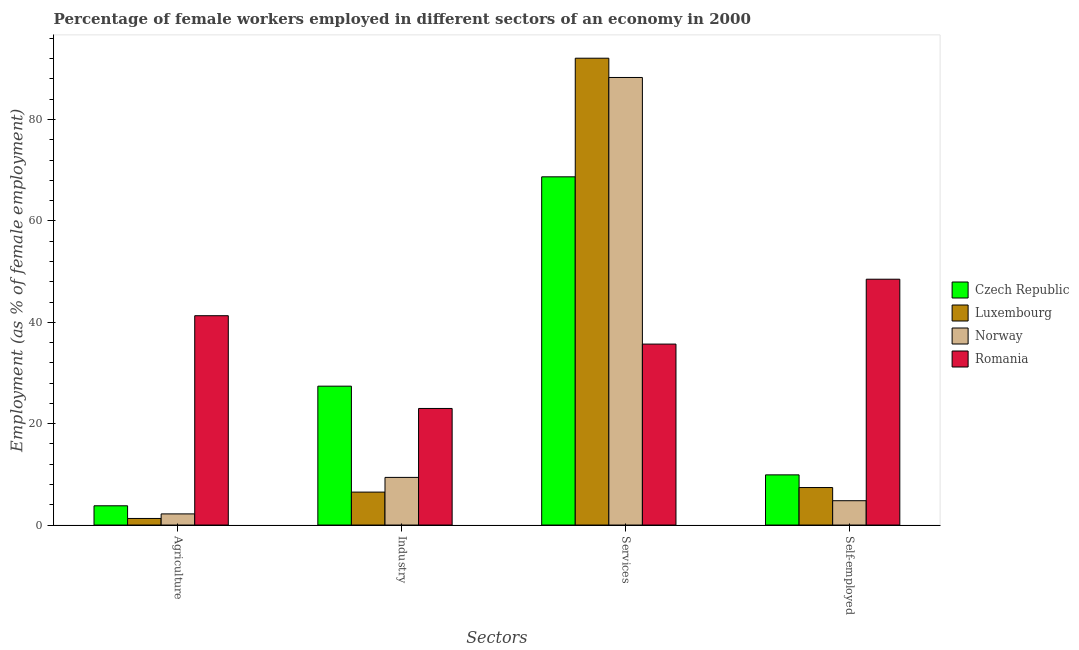How many different coloured bars are there?
Your answer should be very brief. 4. How many groups of bars are there?
Keep it short and to the point. 4. Are the number of bars on each tick of the X-axis equal?
Provide a short and direct response. Yes. How many bars are there on the 2nd tick from the right?
Provide a short and direct response. 4. What is the label of the 4th group of bars from the left?
Ensure brevity in your answer.  Self-employed. What is the percentage of female workers in agriculture in Luxembourg?
Your answer should be compact. 1.3. Across all countries, what is the maximum percentage of self employed female workers?
Offer a terse response. 48.5. Across all countries, what is the minimum percentage of female workers in agriculture?
Give a very brief answer. 1.3. In which country was the percentage of female workers in industry maximum?
Give a very brief answer. Czech Republic. What is the total percentage of female workers in services in the graph?
Ensure brevity in your answer.  284.8. What is the difference between the percentage of self employed female workers in Luxembourg and that in Norway?
Offer a very short reply. 2.6. What is the difference between the percentage of female workers in agriculture in Norway and the percentage of female workers in services in Luxembourg?
Your response must be concise. -89.9. What is the average percentage of female workers in industry per country?
Keep it short and to the point. 16.57. What is the difference between the percentage of female workers in services and percentage of female workers in agriculture in Luxembourg?
Keep it short and to the point. 90.8. What is the ratio of the percentage of female workers in services in Luxembourg to that in Czech Republic?
Offer a terse response. 1.34. Is the percentage of female workers in industry in Romania less than that in Norway?
Your answer should be compact. No. What is the difference between the highest and the second highest percentage of self employed female workers?
Keep it short and to the point. 38.6. What is the difference between the highest and the lowest percentage of female workers in services?
Your answer should be compact. 56.4. In how many countries, is the percentage of female workers in industry greater than the average percentage of female workers in industry taken over all countries?
Ensure brevity in your answer.  2. Is the sum of the percentage of self employed female workers in Luxembourg and Norway greater than the maximum percentage of female workers in industry across all countries?
Offer a very short reply. No. Is it the case that in every country, the sum of the percentage of self employed female workers and percentage of female workers in agriculture is greater than the sum of percentage of female workers in services and percentage of female workers in industry?
Your answer should be compact. No. What does the 4th bar from the left in Services represents?
Your answer should be very brief. Romania. What does the 1st bar from the right in Self-employed represents?
Give a very brief answer. Romania. Is it the case that in every country, the sum of the percentage of female workers in agriculture and percentage of female workers in industry is greater than the percentage of female workers in services?
Provide a succinct answer. No. How many bars are there?
Your answer should be compact. 16. Are the values on the major ticks of Y-axis written in scientific E-notation?
Provide a succinct answer. No. Does the graph contain grids?
Give a very brief answer. No. Where does the legend appear in the graph?
Your answer should be very brief. Center right. What is the title of the graph?
Ensure brevity in your answer.  Percentage of female workers employed in different sectors of an economy in 2000. What is the label or title of the X-axis?
Your answer should be very brief. Sectors. What is the label or title of the Y-axis?
Make the answer very short. Employment (as % of female employment). What is the Employment (as % of female employment) in Czech Republic in Agriculture?
Your answer should be compact. 3.8. What is the Employment (as % of female employment) of Luxembourg in Agriculture?
Keep it short and to the point. 1.3. What is the Employment (as % of female employment) of Norway in Agriculture?
Keep it short and to the point. 2.2. What is the Employment (as % of female employment) in Romania in Agriculture?
Your answer should be very brief. 41.3. What is the Employment (as % of female employment) of Czech Republic in Industry?
Your response must be concise. 27.4. What is the Employment (as % of female employment) of Norway in Industry?
Keep it short and to the point. 9.4. What is the Employment (as % of female employment) in Romania in Industry?
Your answer should be compact. 23. What is the Employment (as % of female employment) of Czech Republic in Services?
Offer a very short reply. 68.7. What is the Employment (as % of female employment) of Luxembourg in Services?
Your answer should be compact. 92.1. What is the Employment (as % of female employment) of Norway in Services?
Provide a short and direct response. 88.3. What is the Employment (as % of female employment) in Romania in Services?
Offer a very short reply. 35.7. What is the Employment (as % of female employment) of Czech Republic in Self-employed?
Your answer should be compact. 9.9. What is the Employment (as % of female employment) of Luxembourg in Self-employed?
Provide a succinct answer. 7.4. What is the Employment (as % of female employment) in Norway in Self-employed?
Offer a terse response. 4.8. What is the Employment (as % of female employment) in Romania in Self-employed?
Keep it short and to the point. 48.5. Across all Sectors, what is the maximum Employment (as % of female employment) in Czech Republic?
Keep it short and to the point. 68.7. Across all Sectors, what is the maximum Employment (as % of female employment) in Luxembourg?
Offer a terse response. 92.1. Across all Sectors, what is the maximum Employment (as % of female employment) of Norway?
Ensure brevity in your answer.  88.3. Across all Sectors, what is the maximum Employment (as % of female employment) of Romania?
Provide a short and direct response. 48.5. Across all Sectors, what is the minimum Employment (as % of female employment) in Czech Republic?
Offer a terse response. 3.8. Across all Sectors, what is the minimum Employment (as % of female employment) in Luxembourg?
Provide a succinct answer. 1.3. Across all Sectors, what is the minimum Employment (as % of female employment) of Norway?
Offer a terse response. 2.2. What is the total Employment (as % of female employment) of Czech Republic in the graph?
Make the answer very short. 109.8. What is the total Employment (as % of female employment) of Luxembourg in the graph?
Make the answer very short. 107.3. What is the total Employment (as % of female employment) in Norway in the graph?
Keep it short and to the point. 104.7. What is the total Employment (as % of female employment) of Romania in the graph?
Provide a short and direct response. 148.5. What is the difference between the Employment (as % of female employment) of Czech Republic in Agriculture and that in Industry?
Provide a short and direct response. -23.6. What is the difference between the Employment (as % of female employment) of Norway in Agriculture and that in Industry?
Your answer should be compact. -7.2. What is the difference between the Employment (as % of female employment) of Czech Republic in Agriculture and that in Services?
Ensure brevity in your answer.  -64.9. What is the difference between the Employment (as % of female employment) in Luxembourg in Agriculture and that in Services?
Offer a terse response. -90.8. What is the difference between the Employment (as % of female employment) of Norway in Agriculture and that in Services?
Offer a very short reply. -86.1. What is the difference between the Employment (as % of female employment) of Romania in Agriculture and that in Services?
Your answer should be compact. 5.6. What is the difference between the Employment (as % of female employment) in Czech Republic in Agriculture and that in Self-employed?
Give a very brief answer. -6.1. What is the difference between the Employment (as % of female employment) of Romania in Agriculture and that in Self-employed?
Your response must be concise. -7.2. What is the difference between the Employment (as % of female employment) of Czech Republic in Industry and that in Services?
Provide a short and direct response. -41.3. What is the difference between the Employment (as % of female employment) of Luxembourg in Industry and that in Services?
Provide a short and direct response. -85.6. What is the difference between the Employment (as % of female employment) of Norway in Industry and that in Services?
Offer a very short reply. -78.9. What is the difference between the Employment (as % of female employment) of Romania in Industry and that in Services?
Your answer should be compact. -12.7. What is the difference between the Employment (as % of female employment) of Czech Republic in Industry and that in Self-employed?
Ensure brevity in your answer.  17.5. What is the difference between the Employment (as % of female employment) of Luxembourg in Industry and that in Self-employed?
Ensure brevity in your answer.  -0.9. What is the difference between the Employment (as % of female employment) of Romania in Industry and that in Self-employed?
Your answer should be compact. -25.5. What is the difference between the Employment (as % of female employment) in Czech Republic in Services and that in Self-employed?
Your response must be concise. 58.8. What is the difference between the Employment (as % of female employment) in Luxembourg in Services and that in Self-employed?
Make the answer very short. 84.7. What is the difference between the Employment (as % of female employment) of Norway in Services and that in Self-employed?
Your response must be concise. 83.5. What is the difference between the Employment (as % of female employment) in Czech Republic in Agriculture and the Employment (as % of female employment) in Norway in Industry?
Make the answer very short. -5.6. What is the difference between the Employment (as % of female employment) of Czech Republic in Agriculture and the Employment (as % of female employment) of Romania in Industry?
Provide a short and direct response. -19.2. What is the difference between the Employment (as % of female employment) in Luxembourg in Agriculture and the Employment (as % of female employment) in Romania in Industry?
Offer a terse response. -21.7. What is the difference between the Employment (as % of female employment) of Norway in Agriculture and the Employment (as % of female employment) of Romania in Industry?
Provide a short and direct response. -20.8. What is the difference between the Employment (as % of female employment) in Czech Republic in Agriculture and the Employment (as % of female employment) in Luxembourg in Services?
Give a very brief answer. -88.3. What is the difference between the Employment (as % of female employment) in Czech Republic in Agriculture and the Employment (as % of female employment) in Norway in Services?
Make the answer very short. -84.5. What is the difference between the Employment (as % of female employment) of Czech Republic in Agriculture and the Employment (as % of female employment) of Romania in Services?
Keep it short and to the point. -31.9. What is the difference between the Employment (as % of female employment) in Luxembourg in Agriculture and the Employment (as % of female employment) in Norway in Services?
Give a very brief answer. -87. What is the difference between the Employment (as % of female employment) in Luxembourg in Agriculture and the Employment (as % of female employment) in Romania in Services?
Make the answer very short. -34.4. What is the difference between the Employment (as % of female employment) of Norway in Agriculture and the Employment (as % of female employment) of Romania in Services?
Your response must be concise. -33.5. What is the difference between the Employment (as % of female employment) in Czech Republic in Agriculture and the Employment (as % of female employment) in Luxembourg in Self-employed?
Offer a terse response. -3.6. What is the difference between the Employment (as % of female employment) in Czech Republic in Agriculture and the Employment (as % of female employment) in Norway in Self-employed?
Your answer should be compact. -1. What is the difference between the Employment (as % of female employment) of Czech Republic in Agriculture and the Employment (as % of female employment) of Romania in Self-employed?
Offer a very short reply. -44.7. What is the difference between the Employment (as % of female employment) in Luxembourg in Agriculture and the Employment (as % of female employment) in Norway in Self-employed?
Your response must be concise. -3.5. What is the difference between the Employment (as % of female employment) of Luxembourg in Agriculture and the Employment (as % of female employment) of Romania in Self-employed?
Your answer should be compact. -47.2. What is the difference between the Employment (as % of female employment) in Norway in Agriculture and the Employment (as % of female employment) in Romania in Self-employed?
Your answer should be compact. -46.3. What is the difference between the Employment (as % of female employment) in Czech Republic in Industry and the Employment (as % of female employment) in Luxembourg in Services?
Your answer should be compact. -64.7. What is the difference between the Employment (as % of female employment) of Czech Republic in Industry and the Employment (as % of female employment) of Norway in Services?
Your answer should be very brief. -60.9. What is the difference between the Employment (as % of female employment) of Luxembourg in Industry and the Employment (as % of female employment) of Norway in Services?
Your answer should be very brief. -81.8. What is the difference between the Employment (as % of female employment) of Luxembourg in Industry and the Employment (as % of female employment) of Romania in Services?
Your answer should be compact. -29.2. What is the difference between the Employment (as % of female employment) in Norway in Industry and the Employment (as % of female employment) in Romania in Services?
Your answer should be compact. -26.3. What is the difference between the Employment (as % of female employment) in Czech Republic in Industry and the Employment (as % of female employment) in Luxembourg in Self-employed?
Provide a short and direct response. 20. What is the difference between the Employment (as % of female employment) in Czech Republic in Industry and the Employment (as % of female employment) in Norway in Self-employed?
Provide a short and direct response. 22.6. What is the difference between the Employment (as % of female employment) of Czech Republic in Industry and the Employment (as % of female employment) of Romania in Self-employed?
Your answer should be very brief. -21.1. What is the difference between the Employment (as % of female employment) in Luxembourg in Industry and the Employment (as % of female employment) in Norway in Self-employed?
Provide a short and direct response. 1.7. What is the difference between the Employment (as % of female employment) in Luxembourg in Industry and the Employment (as % of female employment) in Romania in Self-employed?
Keep it short and to the point. -42. What is the difference between the Employment (as % of female employment) of Norway in Industry and the Employment (as % of female employment) of Romania in Self-employed?
Make the answer very short. -39.1. What is the difference between the Employment (as % of female employment) of Czech Republic in Services and the Employment (as % of female employment) of Luxembourg in Self-employed?
Provide a succinct answer. 61.3. What is the difference between the Employment (as % of female employment) of Czech Republic in Services and the Employment (as % of female employment) of Norway in Self-employed?
Provide a short and direct response. 63.9. What is the difference between the Employment (as % of female employment) in Czech Republic in Services and the Employment (as % of female employment) in Romania in Self-employed?
Your answer should be very brief. 20.2. What is the difference between the Employment (as % of female employment) in Luxembourg in Services and the Employment (as % of female employment) in Norway in Self-employed?
Your response must be concise. 87.3. What is the difference between the Employment (as % of female employment) of Luxembourg in Services and the Employment (as % of female employment) of Romania in Self-employed?
Your response must be concise. 43.6. What is the difference between the Employment (as % of female employment) of Norway in Services and the Employment (as % of female employment) of Romania in Self-employed?
Your response must be concise. 39.8. What is the average Employment (as % of female employment) of Czech Republic per Sectors?
Provide a succinct answer. 27.45. What is the average Employment (as % of female employment) in Luxembourg per Sectors?
Offer a very short reply. 26.82. What is the average Employment (as % of female employment) of Norway per Sectors?
Your response must be concise. 26.18. What is the average Employment (as % of female employment) in Romania per Sectors?
Your answer should be compact. 37.12. What is the difference between the Employment (as % of female employment) of Czech Republic and Employment (as % of female employment) of Romania in Agriculture?
Ensure brevity in your answer.  -37.5. What is the difference between the Employment (as % of female employment) of Norway and Employment (as % of female employment) of Romania in Agriculture?
Keep it short and to the point. -39.1. What is the difference between the Employment (as % of female employment) of Czech Republic and Employment (as % of female employment) of Luxembourg in Industry?
Offer a terse response. 20.9. What is the difference between the Employment (as % of female employment) of Czech Republic and Employment (as % of female employment) of Norway in Industry?
Make the answer very short. 18. What is the difference between the Employment (as % of female employment) in Czech Republic and Employment (as % of female employment) in Romania in Industry?
Provide a short and direct response. 4.4. What is the difference between the Employment (as % of female employment) of Luxembourg and Employment (as % of female employment) of Norway in Industry?
Make the answer very short. -2.9. What is the difference between the Employment (as % of female employment) of Luxembourg and Employment (as % of female employment) of Romania in Industry?
Give a very brief answer. -16.5. What is the difference between the Employment (as % of female employment) in Norway and Employment (as % of female employment) in Romania in Industry?
Give a very brief answer. -13.6. What is the difference between the Employment (as % of female employment) in Czech Republic and Employment (as % of female employment) in Luxembourg in Services?
Offer a very short reply. -23.4. What is the difference between the Employment (as % of female employment) in Czech Republic and Employment (as % of female employment) in Norway in Services?
Give a very brief answer. -19.6. What is the difference between the Employment (as % of female employment) in Czech Republic and Employment (as % of female employment) in Romania in Services?
Offer a very short reply. 33. What is the difference between the Employment (as % of female employment) of Luxembourg and Employment (as % of female employment) of Norway in Services?
Provide a succinct answer. 3.8. What is the difference between the Employment (as % of female employment) of Luxembourg and Employment (as % of female employment) of Romania in Services?
Offer a very short reply. 56.4. What is the difference between the Employment (as % of female employment) in Norway and Employment (as % of female employment) in Romania in Services?
Make the answer very short. 52.6. What is the difference between the Employment (as % of female employment) in Czech Republic and Employment (as % of female employment) in Romania in Self-employed?
Your answer should be very brief. -38.6. What is the difference between the Employment (as % of female employment) in Luxembourg and Employment (as % of female employment) in Norway in Self-employed?
Provide a short and direct response. 2.6. What is the difference between the Employment (as % of female employment) in Luxembourg and Employment (as % of female employment) in Romania in Self-employed?
Keep it short and to the point. -41.1. What is the difference between the Employment (as % of female employment) of Norway and Employment (as % of female employment) of Romania in Self-employed?
Offer a very short reply. -43.7. What is the ratio of the Employment (as % of female employment) in Czech Republic in Agriculture to that in Industry?
Ensure brevity in your answer.  0.14. What is the ratio of the Employment (as % of female employment) in Norway in Agriculture to that in Industry?
Give a very brief answer. 0.23. What is the ratio of the Employment (as % of female employment) of Romania in Agriculture to that in Industry?
Provide a succinct answer. 1.8. What is the ratio of the Employment (as % of female employment) in Czech Republic in Agriculture to that in Services?
Give a very brief answer. 0.06. What is the ratio of the Employment (as % of female employment) in Luxembourg in Agriculture to that in Services?
Make the answer very short. 0.01. What is the ratio of the Employment (as % of female employment) in Norway in Agriculture to that in Services?
Give a very brief answer. 0.02. What is the ratio of the Employment (as % of female employment) of Romania in Agriculture to that in Services?
Make the answer very short. 1.16. What is the ratio of the Employment (as % of female employment) in Czech Republic in Agriculture to that in Self-employed?
Offer a terse response. 0.38. What is the ratio of the Employment (as % of female employment) in Luxembourg in Agriculture to that in Self-employed?
Your response must be concise. 0.18. What is the ratio of the Employment (as % of female employment) of Norway in Agriculture to that in Self-employed?
Your response must be concise. 0.46. What is the ratio of the Employment (as % of female employment) in Romania in Agriculture to that in Self-employed?
Make the answer very short. 0.85. What is the ratio of the Employment (as % of female employment) in Czech Republic in Industry to that in Services?
Make the answer very short. 0.4. What is the ratio of the Employment (as % of female employment) in Luxembourg in Industry to that in Services?
Your response must be concise. 0.07. What is the ratio of the Employment (as % of female employment) in Norway in Industry to that in Services?
Your answer should be very brief. 0.11. What is the ratio of the Employment (as % of female employment) of Romania in Industry to that in Services?
Provide a short and direct response. 0.64. What is the ratio of the Employment (as % of female employment) in Czech Republic in Industry to that in Self-employed?
Offer a terse response. 2.77. What is the ratio of the Employment (as % of female employment) of Luxembourg in Industry to that in Self-employed?
Give a very brief answer. 0.88. What is the ratio of the Employment (as % of female employment) in Norway in Industry to that in Self-employed?
Provide a short and direct response. 1.96. What is the ratio of the Employment (as % of female employment) in Romania in Industry to that in Self-employed?
Your answer should be compact. 0.47. What is the ratio of the Employment (as % of female employment) of Czech Republic in Services to that in Self-employed?
Offer a terse response. 6.94. What is the ratio of the Employment (as % of female employment) in Luxembourg in Services to that in Self-employed?
Keep it short and to the point. 12.45. What is the ratio of the Employment (as % of female employment) of Norway in Services to that in Self-employed?
Your response must be concise. 18.4. What is the ratio of the Employment (as % of female employment) in Romania in Services to that in Self-employed?
Ensure brevity in your answer.  0.74. What is the difference between the highest and the second highest Employment (as % of female employment) of Czech Republic?
Give a very brief answer. 41.3. What is the difference between the highest and the second highest Employment (as % of female employment) in Luxembourg?
Give a very brief answer. 84.7. What is the difference between the highest and the second highest Employment (as % of female employment) in Norway?
Your response must be concise. 78.9. What is the difference between the highest and the lowest Employment (as % of female employment) of Czech Republic?
Offer a very short reply. 64.9. What is the difference between the highest and the lowest Employment (as % of female employment) in Luxembourg?
Offer a terse response. 90.8. What is the difference between the highest and the lowest Employment (as % of female employment) of Norway?
Your answer should be compact. 86.1. 